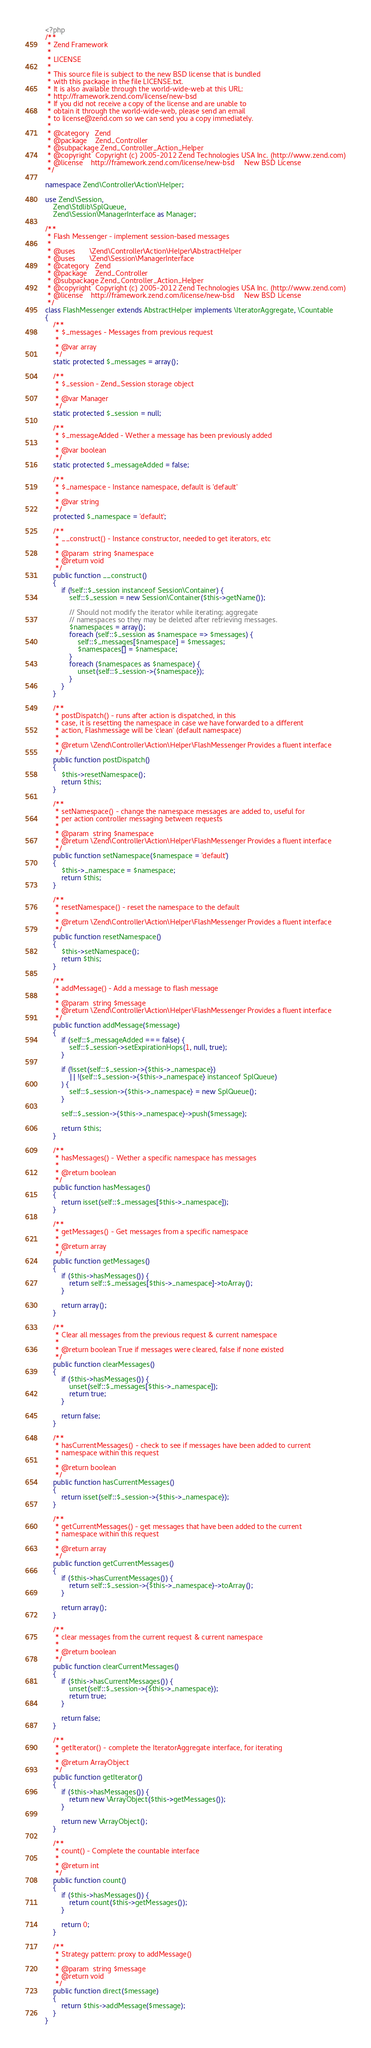<code> <loc_0><loc_0><loc_500><loc_500><_PHP_><?php
/**
 * Zend Framework
 *
 * LICENSE
 *
 * This source file is subject to the new BSD license that is bundled
 * with this package in the file LICENSE.txt.
 * It is also available through the world-wide-web at this URL:
 * http://framework.zend.com/license/new-bsd
 * If you did not receive a copy of the license and are unable to
 * obtain it through the world-wide-web, please send an email
 * to license@zend.com so we can send you a copy immediately.
 *
 * @category   Zend
 * @package    Zend_Controller
 * @subpackage Zend_Controller_Action_Helper
 * @copyright  Copyright (c) 2005-2012 Zend Technologies USA Inc. (http://www.zend.com)
 * @license    http://framework.zend.com/license/new-bsd     New BSD License
 */

namespace Zend\Controller\Action\Helper;

use Zend\Session,
    Zend\Stdlib\SplQueue,
    Zend\Session\ManagerInterface as Manager;

/**
 * Flash Messenger - implement session-based messages
 *
 * @uses       \Zend\Controller\Action\Helper\AbstractHelper
 * @uses       \Zend\Session\ManagerInterface
 * @category   Zend
 * @package    Zend_Controller
 * @subpackage Zend_Controller_Action_Helper
 * @copyright  Copyright (c) 2005-2012 Zend Technologies USA Inc. (http://www.zend.com)
 * @license    http://framework.zend.com/license/new-bsd     New BSD License
 */
class FlashMessenger extends AbstractHelper implements \IteratorAggregate, \Countable
{
    /**
     * $_messages - Messages from previous request
     *
     * @var array
     */
    static protected $_messages = array();

    /**
     * $_session - Zend_Session storage object
     *
     * @var Manager
     */
    static protected $_session = null;

    /**
     * $_messageAdded - Wether a message has been previously added
     *
     * @var boolean
     */
    static protected $_messageAdded = false;

    /**
     * $_namespace - Instance namespace, default is 'default'
     *
     * @var string
     */
    protected $_namespace = 'default';

    /**
     * __construct() - Instance constructor, needed to get iterators, etc
     *
     * @param  string $namespace
     * @return void
     */
    public function __construct()
    {
        if (!self::$_session instanceof Session\Container) {
            self::$_session = new Session\Container($this->getName());

            // Should not modify the iterator while iterating; aggregate 
            // namespaces so they may be deleted after retrieving messages.
            $namespaces = array();
            foreach (self::$_session as $namespace => $messages) {
                self::$_messages[$namespace] = $messages;
                $namespaces[] = $namespace;
            }
            foreach ($namespaces as $namespace) {
                unset(self::$_session->{$namespace});
            }
        }
    }

    /**
     * postDispatch() - runs after action is dispatched, in this
     * case, it is resetting the namespace in case we have forwarded to a different
     * action, Flashmessage will be 'clean' (default namespace)
     *
     * @return \Zend\Controller\Action\Helper\FlashMessenger Provides a fluent interface
     */
    public function postDispatch()
    {
        $this->resetNamespace();
        return $this;
    }

    /**
     * setNamespace() - change the namespace messages are added to, useful for
     * per action controller messaging between requests
     *
     * @param  string $namespace
     * @return \Zend\Controller\Action\Helper\FlashMessenger Provides a fluent interface
     */
    public function setNamespace($namespace = 'default')
    {
        $this->_namespace = $namespace;
        return $this;
    }

    /**
     * resetNamespace() - reset the namespace to the default
     *
     * @return \Zend\Controller\Action\Helper\FlashMessenger Provides a fluent interface
     */
    public function resetNamespace()
    {
        $this->setNamespace();
        return $this;
    }

    /**
     * addMessage() - Add a message to flash message
     *
     * @param  string $message
     * @return \Zend\Controller\Action\Helper\FlashMessenger Provides a fluent interface
     */
    public function addMessage($message)
    {
        if (self::$_messageAdded === false) {
            self::$_session->setExpirationHops(1, null, true);
        }

        if (!isset(self::$_session->{$this->_namespace})
            || !(self::$_session->{$this->_namespace} instanceof SplQueue)
        ) {
            self::$_session->{$this->_namespace} = new SplQueue();
        }

        self::$_session->{$this->_namespace}->push($message);

        return $this;
    }

    /**
     * hasMessages() - Wether a specific namespace has messages
     *
     * @return boolean
     */
    public function hasMessages()
    {
        return isset(self::$_messages[$this->_namespace]);
    }

    /**
     * getMessages() - Get messages from a specific namespace
     *
     * @return array
     */
    public function getMessages()
    {
        if ($this->hasMessages()) {
            return self::$_messages[$this->_namespace]->toArray();
        }

        return array();
    }

    /**
     * Clear all messages from the previous request & current namespace
     *
     * @return boolean True if messages were cleared, false if none existed
     */
    public function clearMessages()
    {
        if ($this->hasMessages()) {
            unset(self::$_messages[$this->_namespace]);
            return true;
        }

        return false;
    }

    /**
     * hasCurrentMessages() - check to see if messages have been added to current
     * namespace within this request
     *
     * @return boolean
     */
    public function hasCurrentMessages()
    {
        return isset(self::$_session->{$this->_namespace});
    }

    /**
     * getCurrentMessages() - get messages that have been added to the current
     * namespace within this request
     *
     * @return array
     */
    public function getCurrentMessages()
    {
        if ($this->hasCurrentMessages()) {
            return self::$_session->{$this->_namespace}->toArray();
        }

        return array();
    }

    /**
     * clear messages from the current request & current namespace
     *
     * @return boolean
     */
    public function clearCurrentMessages()
    {
        if ($this->hasCurrentMessages()) {
            unset(self::$_session->{$this->_namespace});
            return true;
        }

        return false;
    }

    /**
     * getIterator() - complete the IteratorAggregate interface, for iterating
     *
     * @return ArrayObject
     */
    public function getIterator()
    {
        if ($this->hasMessages()) {
            return new \ArrayObject($this->getMessages());
        }

        return new \ArrayObject();
    }

    /**
     * count() - Complete the countable interface
     *
     * @return int
     */
    public function count()
    {
        if ($this->hasMessages()) {
            return count($this->getMessages());
        }

        return 0;
    }

    /**
     * Strategy pattern: proxy to addMessage()
     *
     * @param  string $message
     * @return void
     */
    public function direct($message)
    {
        return $this->addMessage($message);
    }
}
</code> 